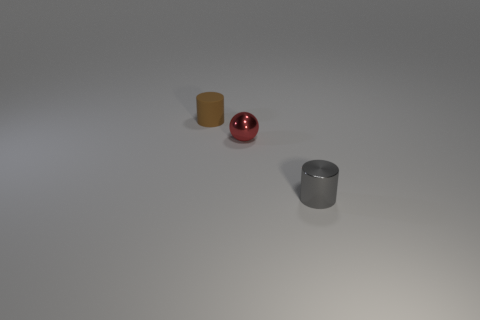Add 1 tiny brown matte things. How many objects exist? 4 Subtract all spheres. How many objects are left? 2 Add 1 brown rubber cylinders. How many brown rubber cylinders exist? 2 Subtract 0 cyan cylinders. How many objects are left? 3 Subtract all big purple rubber objects. Subtract all small red spheres. How many objects are left? 2 Add 2 tiny red things. How many tiny red things are left? 3 